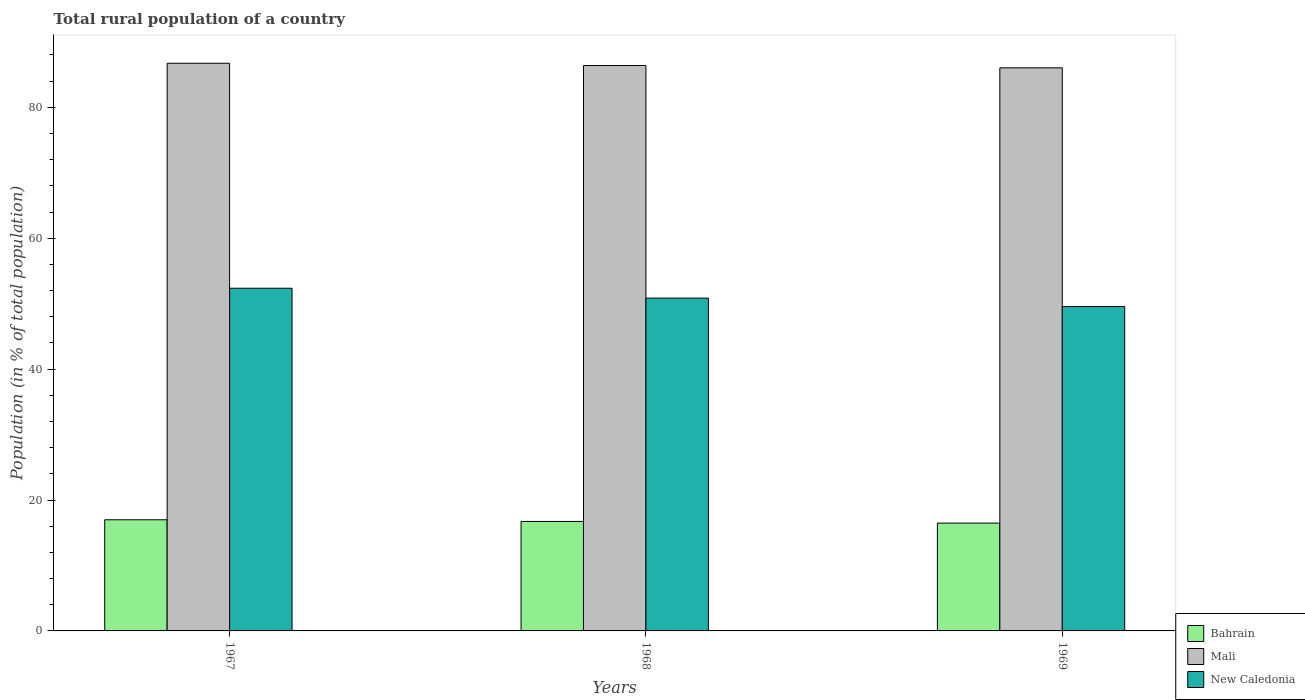How many different coloured bars are there?
Your answer should be very brief. 3. Are the number of bars per tick equal to the number of legend labels?
Offer a very short reply. Yes. How many bars are there on the 2nd tick from the left?
Provide a short and direct response. 3. How many bars are there on the 3rd tick from the right?
Keep it short and to the point. 3. What is the label of the 2nd group of bars from the left?
Provide a succinct answer. 1968. In how many cases, is the number of bars for a given year not equal to the number of legend labels?
Give a very brief answer. 0. What is the rural population in New Caledonia in 1967?
Ensure brevity in your answer.  52.35. Across all years, what is the maximum rural population in New Caledonia?
Your answer should be very brief. 52.35. Across all years, what is the minimum rural population in New Caledonia?
Your response must be concise. 49.56. In which year was the rural population in Bahrain maximum?
Ensure brevity in your answer.  1967. In which year was the rural population in New Caledonia minimum?
Ensure brevity in your answer.  1969. What is the total rural population in Bahrain in the graph?
Offer a very short reply. 50.18. What is the difference between the rural population in New Caledonia in 1968 and that in 1969?
Offer a very short reply. 1.29. What is the difference between the rural population in Bahrain in 1968 and the rural population in Mali in 1967?
Provide a short and direct response. -70. What is the average rural population in Mali per year?
Your response must be concise. 86.38. In the year 1967, what is the difference between the rural population in New Caledonia and rural population in Bahrain?
Provide a short and direct response. 35.37. What is the ratio of the rural population in Mali in 1968 to that in 1969?
Make the answer very short. 1. What is the difference between the highest and the second highest rural population in Bahrain?
Give a very brief answer. 0.26. What is the difference between the highest and the lowest rural population in Mali?
Your response must be concise. 0.7. In how many years, is the rural population in Bahrain greater than the average rural population in Bahrain taken over all years?
Your answer should be very brief. 1. Is the sum of the rural population in Mali in 1967 and 1968 greater than the maximum rural population in New Caledonia across all years?
Provide a succinct answer. Yes. What does the 1st bar from the left in 1967 represents?
Your answer should be very brief. Bahrain. What does the 1st bar from the right in 1969 represents?
Give a very brief answer. New Caledonia. How many years are there in the graph?
Offer a terse response. 3. What is the difference between two consecutive major ticks on the Y-axis?
Make the answer very short. 20. Does the graph contain any zero values?
Give a very brief answer. No. Where does the legend appear in the graph?
Provide a short and direct response. Bottom right. What is the title of the graph?
Offer a terse response. Total rural population of a country. What is the label or title of the X-axis?
Your response must be concise. Years. What is the label or title of the Y-axis?
Your response must be concise. Population (in % of total population). What is the Population (in % of total population) of Bahrain in 1967?
Make the answer very short. 16.98. What is the Population (in % of total population) of Mali in 1967?
Ensure brevity in your answer.  86.73. What is the Population (in % of total population) in New Caledonia in 1967?
Provide a succinct answer. 52.35. What is the Population (in % of total population) of Bahrain in 1968?
Your response must be concise. 16.73. What is the Population (in % of total population) in Mali in 1968?
Your answer should be compact. 86.38. What is the Population (in % of total population) of New Caledonia in 1968?
Offer a very short reply. 50.84. What is the Population (in % of total population) in Bahrain in 1969?
Keep it short and to the point. 16.47. What is the Population (in % of total population) in Mali in 1969?
Give a very brief answer. 86.03. What is the Population (in % of total population) in New Caledonia in 1969?
Your answer should be very brief. 49.56. Across all years, what is the maximum Population (in % of total population) in Bahrain?
Your answer should be very brief. 16.98. Across all years, what is the maximum Population (in % of total population) in Mali?
Provide a short and direct response. 86.73. Across all years, what is the maximum Population (in % of total population) in New Caledonia?
Provide a succinct answer. 52.35. Across all years, what is the minimum Population (in % of total population) of Bahrain?
Keep it short and to the point. 16.47. Across all years, what is the minimum Population (in % of total population) of Mali?
Offer a very short reply. 86.03. Across all years, what is the minimum Population (in % of total population) in New Caledonia?
Your answer should be compact. 49.56. What is the total Population (in % of total population) of Bahrain in the graph?
Your answer should be compact. 50.18. What is the total Population (in % of total population) of Mali in the graph?
Keep it short and to the point. 259.14. What is the total Population (in % of total population) of New Caledonia in the graph?
Offer a very short reply. 152.76. What is the difference between the Population (in % of total population) of Bahrain in 1967 and that in 1968?
Make the answer very short. 0.26. What is the difference between the Population (in % of total population) in Mali in 1967 and that in 1968?
Your response must be concise. 0.34. What is the difference between the Population (in % of total population) in New Caledonia in 1967 and that in 1968?
Provide a short and direct response. 1.51. What is the difference between the Population (in % of total population) in Bahrain in 1967 and that in 1969?
Offer a very short reply. 0.51. What is the difference between the Population (in % of total population) of Mali in 1967 and that in 1969?
Provide a short and direct response. 0.7. What is the difference between the Population (in % of total population) of New Caledonia in 1967 and that in 1969?
Your response must be concise. 2.8. What is the difference between the Population (in % of total population) in Bahrain in 1968 and that in 1969?
Your response must be concise. 0.25. What is the difference between the Population (in % of total population) of Mali in 1968 and that in 1969?
Keep it short and to the point. 0.35. What is the difference between the Population (in % of total population) in New Caledonia in 1968 and that in 1969?
Provide a short and direct response. 1.29. What is the difference between the Population (in % of total population) in Bahrain in 1967 and the Population (in % of total population) in Mali in 1968?
Give a very brief answer. -69.4. What is the difference between the Population (in % of total population) in Bahrain in 1967 and the Population (in % of total population) in New Caledonia in 1968?
Your response must be concise. -33.86. What is the difference between the Population (in % of total population) in Mali in 1967 and the Population (in % of total population) in New Caledonia in 1968?
Offer a very short reply. 35.88. What is the difference between the Population (in % of total population) in Bahrain in 1967 and the Population (in % of total population) in Mali in 1969?
Your answer should be compact. -69.05. What is the difference between the Population (in % of total population) of Bahrain in 1967 and the Population (in % of total population) of New Caledonia in 1969?
Offer a terse response. -32.58. What is the difference between the Population (in % of total population) in Mali in 1967 and the Population (in % of total population) in New Caledonia in 1969?
Offer a very short reply. 37.17. What is the difference between the Population (in % of total population) of Bahrain in 1968 and the Population (in % of total population) of Mali in 1969?
Offer a terse response. -69.3. What is the difference between the Population (in % of total population) of Bahrain in 1968 and the Population (in % of total population) of New Caledonia in 1969?
Offer a very short reply. -32.83. What is the difference between the Population (in % of total population) in Mali in 1968 and the Population (in % of total population) in New Caledonia in 1969?
Your answer should be very brief. 36.82. What is the average Population (in % of total population) in Bahrain per year?
Keep it short and to the point. 16.73. What is the average Population (in % of total population) of Mali per year?
Your answer should be compact. 86.38. What is the average Population (in % of total population) of New Caledonia per year?
Provide a short and direct response. 50.92. In the year 1967, what is the difference between the Population (in % of total population) in Bahrain and Population (in % of total population) in Mali?
Make the answer very short. -69.75. In the year 1967, what is the difference between the Population (in % of total population) in Bahrain and Population (in % of total population) in New Caledonia?
Provide a short and direct response. -35.37. In the year 1967, what is the difference between the Population (in % of total population) of Mali and Population (in % of total population) of New Caledonia?
Make the answer very short. 34.37. In the year 1968, what is the difference between the Population (in % of total population) in Bahrain and Population (in % of total population) in Mali?
Offer a very short reply. -69.66. In the year 1968, what is the difference between the Population (in % of total population) in Bahrain and Population (in % of total population) in New Caledonia?
Your answer should be compact. -34.12. In the year 1968, what is the difference between the Population (in % of total population) of Mali and Population (in % of total population) of New Caledonia?
Offer a very short reply. 35.54. In the year 1969, what is the difference between the Population (in % of total population) of Bahrain and Population (in % of total population) of Mali?
Ensure brevity in your answer.  -69.56. In the year 1969, what is the difference between the Population (in % of total population) of Bahrain and Population (in % of total population) of New Caledonia?
Make the answer very short. -33.08. In the year 1969, what is the difference between the Population (in % of total population) in Mali and Population (in % of total population) in New Caledonia?
Make the answer very short. 36.47. What is the ratio of the Population (in % of total population) of Bahrain in 1967 to that in 1968?
Provide a short and direct response. 1.02. What is the ratio of the Population (in % of total population) in New Caledonia in 1967 to that in 1968?
Your answer should be compact. 1.03. What is the ratio of the Population (in % of total population) of Bahrain in 1967 to that in 1969?
Ensure brevity in your answer.  1.03. What is the ratio of the Population (in % of total population) in New Caledonia in 1967 to that in 1969?
Provide a short and direct response. 1.06. What is the ratio of the Population (in % of total population) of Bahrain in 1968 to that in 1969?
Provide a short and direct response. 1.02. What is the ratio of the Population (in % of total population) in New Caledonia in 1968 to that in 1969?
Provide a short and direct response. 1.03. What is the difference between the highest and the second highest Population (in % of total population) of Bahrain?
Provide a short and direct response. 0.26. What is the difference between the highest and the second highest Population (in % of total population) of Mali?
Your answer should be compact. 0.34. What is the difference between the highest and the second highest Population (in % of total population) in New Caledonia?
Your answer should be compact. 1.51. What is the difference between the highest and the lowest Population (in % of total population) of Bahrain?
Offer a very short reply. 0.51. What is the difference between the highest and the lowest Population (in % of total population) of Mali?
Your response must be concise. 0.7. What is the difference between the highest and the lowest Population (in % of total population) of New Caledonia?
Offer a very short reply. 2.8. 